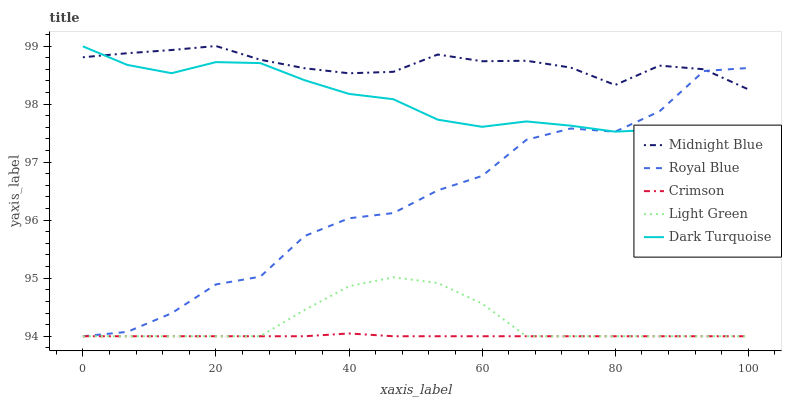Does Royal Blue have the minimum area under the curve?
Answer yes or no. No. Does Royal Blue have the maximum area under the curve?
Answer yes or no. No. Is Midnight Blue the smoothest?
Answer yes or no. No. Is Midnight Blue the roughest?
Answer yes or no. No. Does Midnight Blue have the lowest value?
Answer yes or no. No. Does Royal Blue have the highest value?
Answer yes or no. No. Is Light Green less than Dark Turquoise?
Answer yes or no. Yes. Is Dark Turquoise greater than Crimson?
Answer yes or no. Yes. Does Light Green intersect Dark Turquoise?
Answer yes or no. No. 